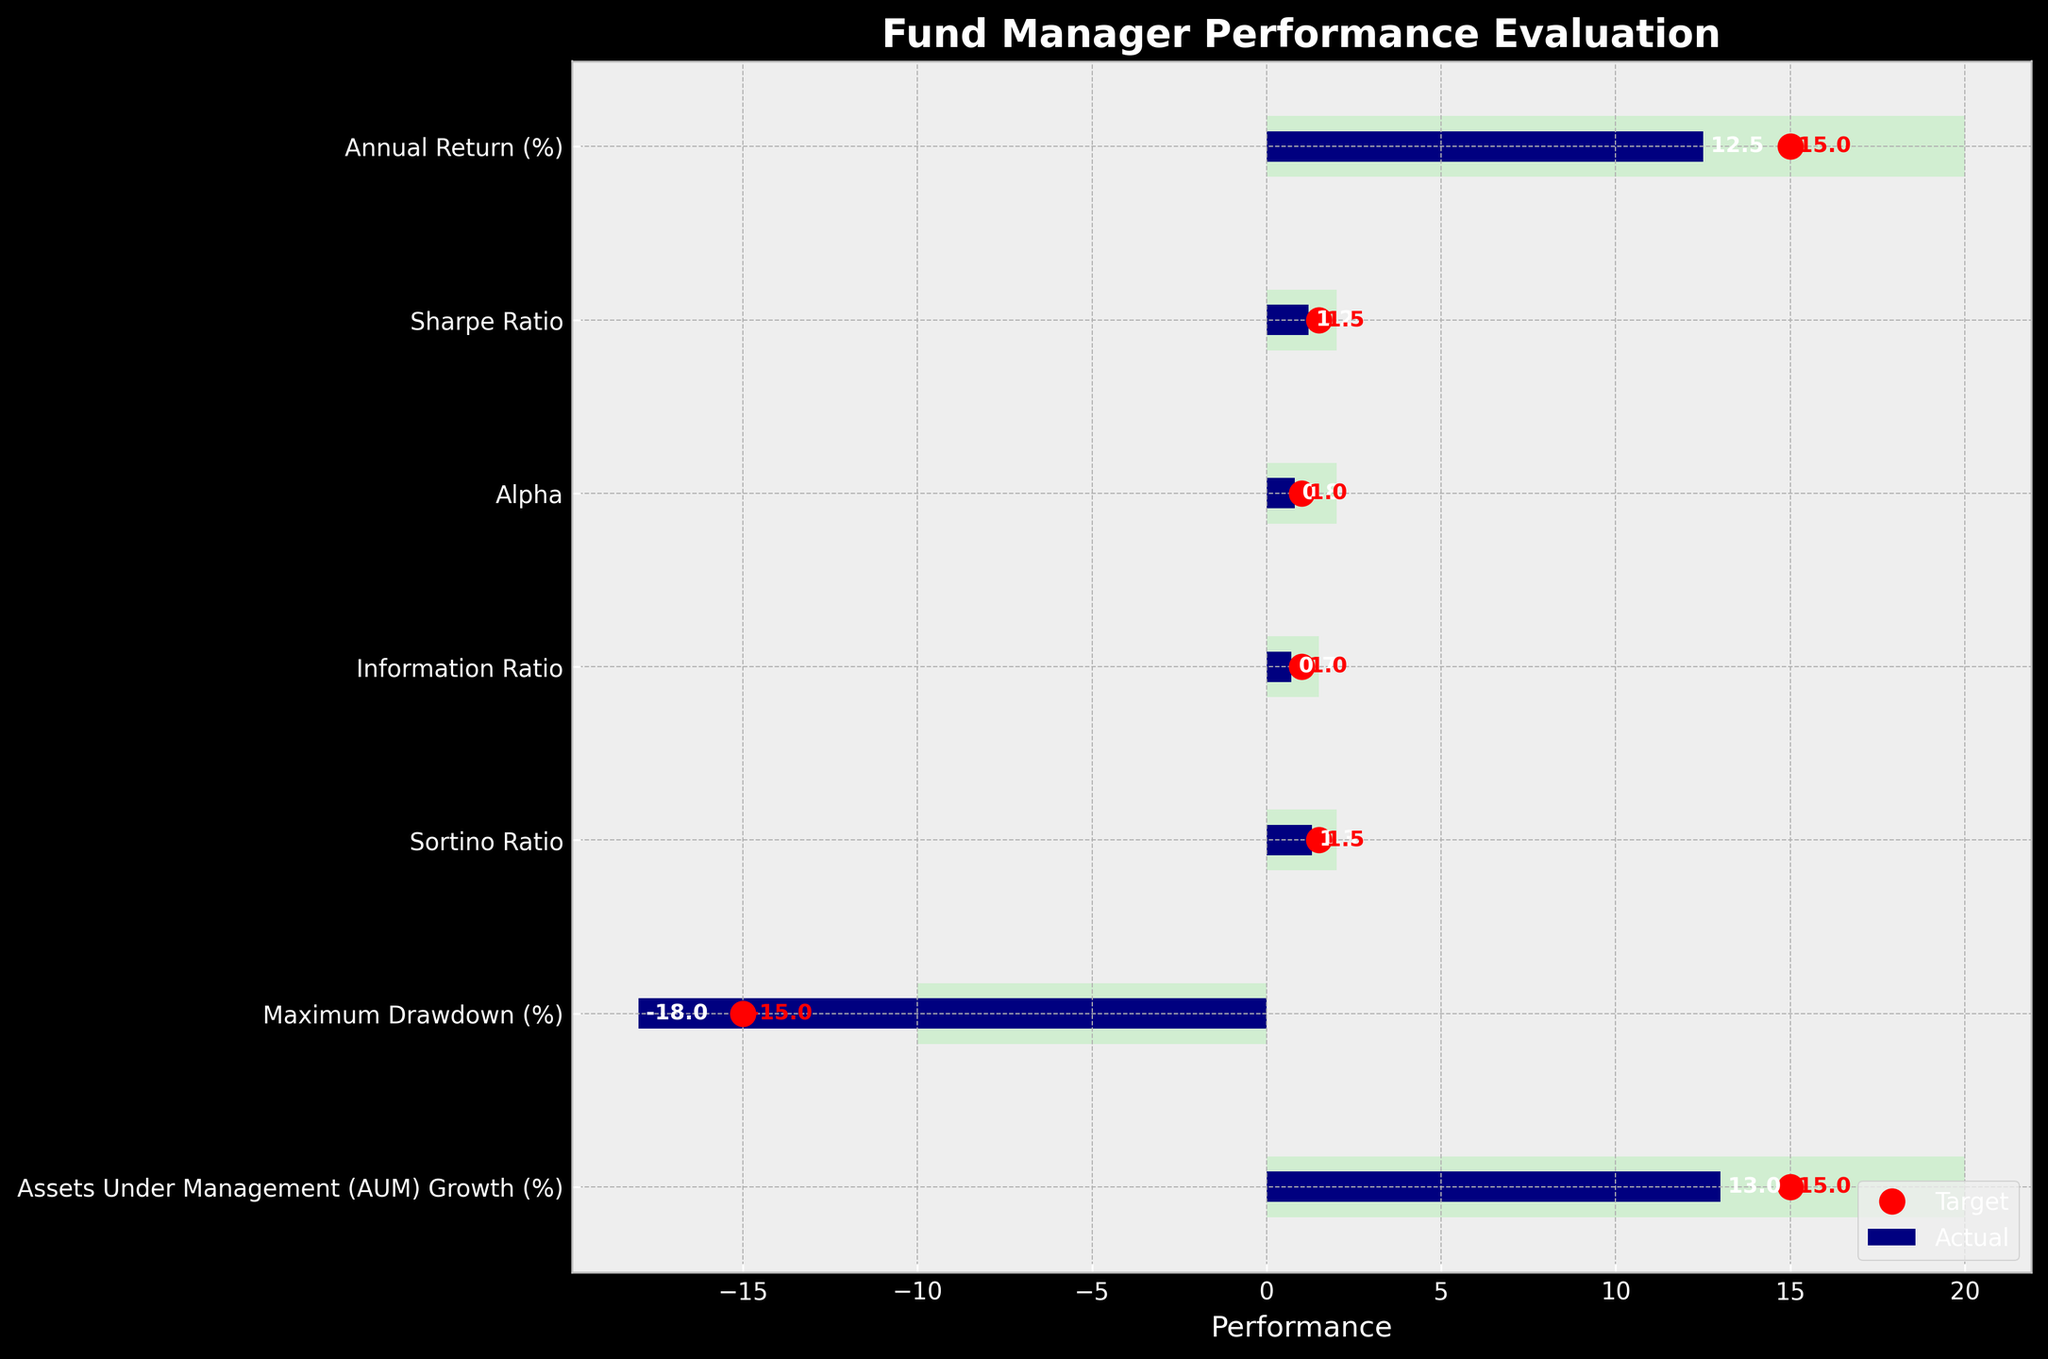What is the title of the figure? The title of the figure is usually found at the top and summarizes the main topic of the chart. It provides a context for the data being visualized. In this chart, the title is "Fund Manager Performance Evaluation".
Answer: Fund Manager Performance Evaluation Which performance metric has the highest actual value? To answer this, we need to look at the actual values for each performance metric and identify the one with the highest numerical value. Comparing them shows that "Annual Return (%)" has the highest actual value of 12.5.
Answer: Annual Return (%) What color represents the actual performance values on the chart? The chart uses color to distinguish different elements. The actual performance values are represented by a navy color as indicated in the bar for each metric.
Answer: Navy What is the target value for the Sharpe Ratio? The target value for each metric is indicated by a red dot on the chart. For the Sharpe Ratio, the target value is indicated next to the red dot, which is 1.5.
Answer: 1.5 What is the range of values considered "Excellent" for the Sharpe Ratio? From the data provided, the "Excellent" range for each metric is listed. For the Sharpe Ratio, the "Excellent" range is from 1.5 to 2.
Answer: 1.5 to 2 What is the most common value for targets across all the metrics? To find the most common target value, list the target values for all the metrics: [15, 1.5, 1, 1, 1.5, -15, 15]. The value 15 appears most frequently (3 times).
Answer: 15 